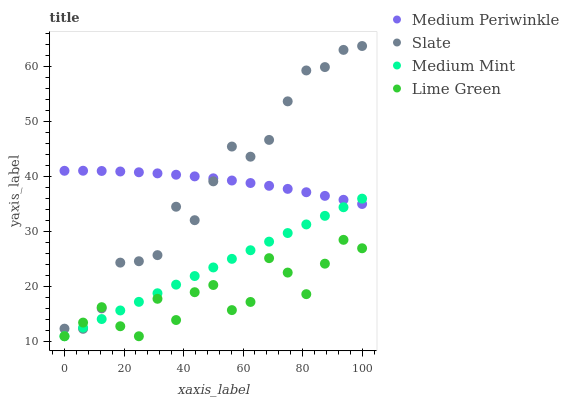Does Lime Green have the minimum area under the curve?
Answer yes or no. Yes. Does Medium Periwinkle have the maximum area under the curve?
Answer yes or no. Yes. Does Slate have the minimum area under the curve?
Answer yes or no. No. Does Slate have the maximum area under the curve?
Answer yes or no. No. Is Medium Mint the smoothest?
Answer yes or no. Yes. Is Lime Green the roughest?
Answer yes or no. Yes. Is Slate the smoothest?
Answer yes or no. No. Is Slate the roughest?
Answer yes or no. No. Does Medium Mint have the lowest value?
Answer yes or no. Yes. Does Slate have the lowest value?
Answer yes or no. No. Does Slate have the highest value?
Answer yes or no. Yes. Does Lime Green have the highest value?
Answer yes or no. No. Is Lime Green less than Medium Periwinkle?
Answer yes or no. Yes. Is Medium Periwinkle greater than Lime Green?
Answer yes or no. Yes. Does Slate intersect Lime Green?
Answer yes or no. Yes. Is Slate less than Lime Green?
Answer yes or no. No. Is Slate greater than Lime Green?
Answer yes or no. No. Does Lime Green intersect Medium Periwinkle?
Answer yes or no. No. 